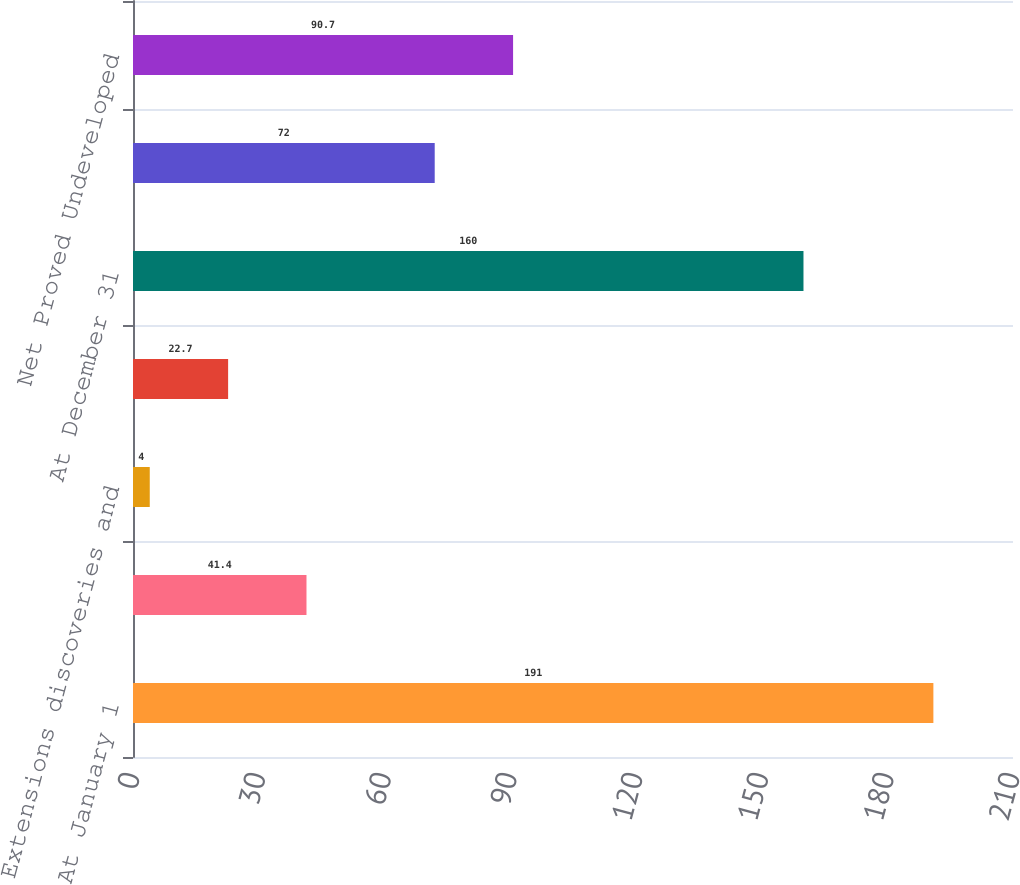<chart> <loc_0><loc_0><loc_500><loc_500><bar_chart><fcel>At January 1<fcel>Revisions of previous<fcel>Extensions discoveries and<fcel>Production<fcel>At December 31<fcel>Net Proved Developed Reserves<fcel>Net Proved Undeveloped<nl><fcel>191<fcel>41.4<fcel>4<fcel>22.7<fcel>160<fcel>72<fcel>90.7<nl></chart> 